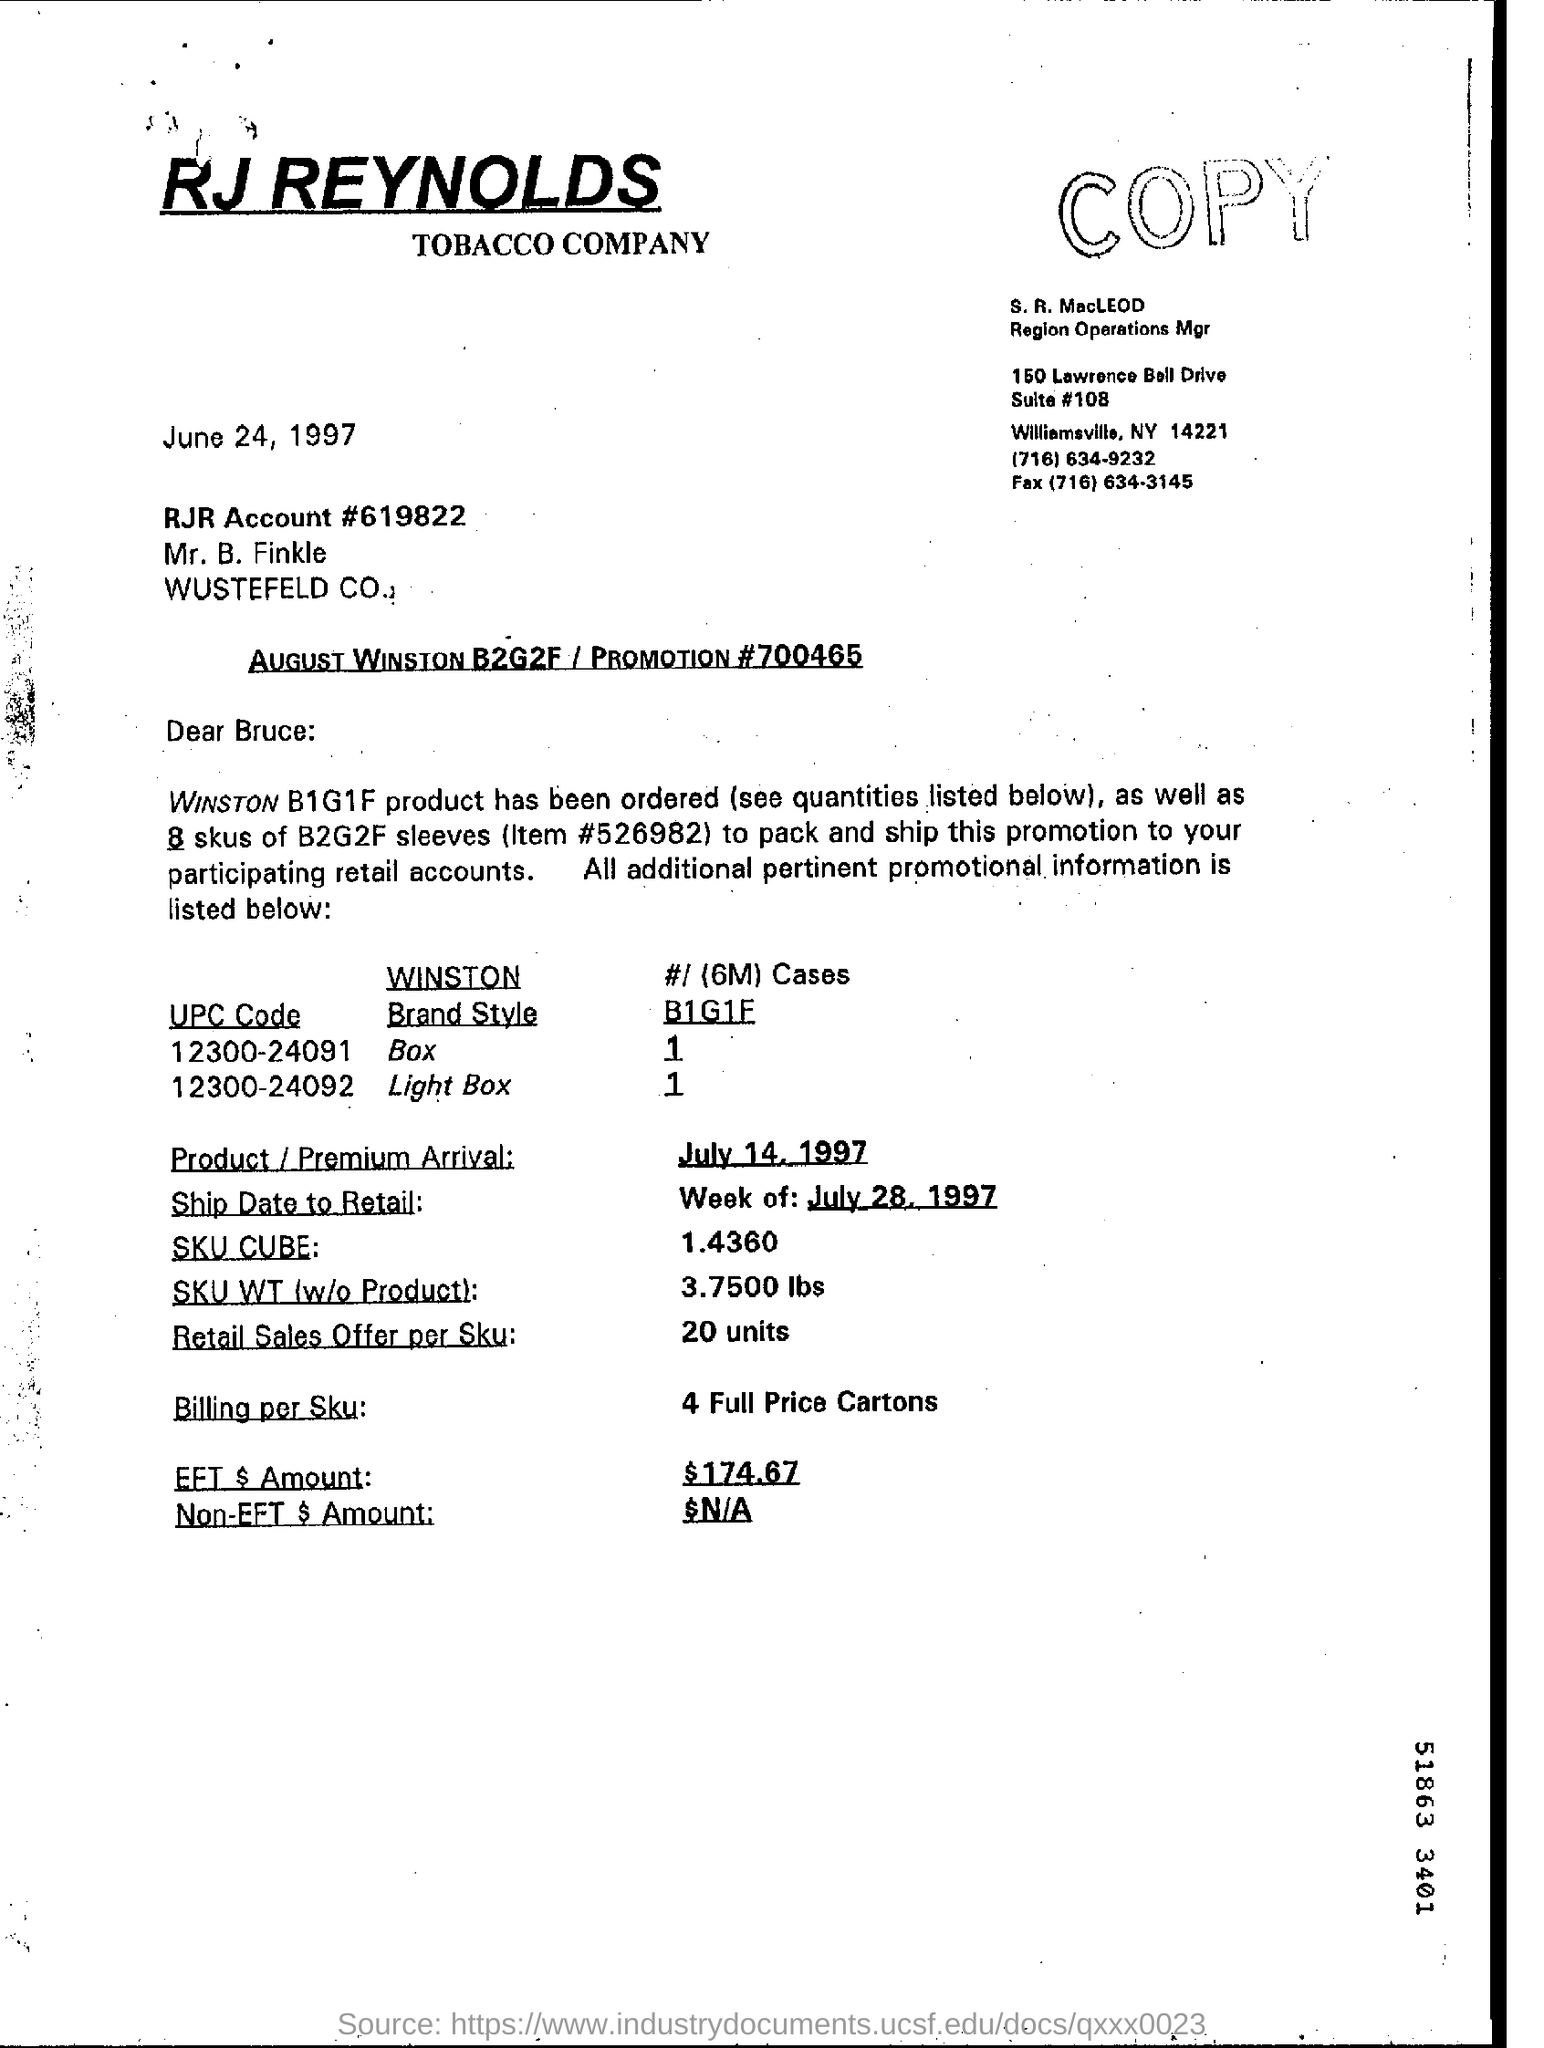Identify some key points in this picture. The date mentioned in the document is June 24, 1997. The RJR Account number is 619822. The UPC code 12300-24092 belongs to the brand style of a light box. 